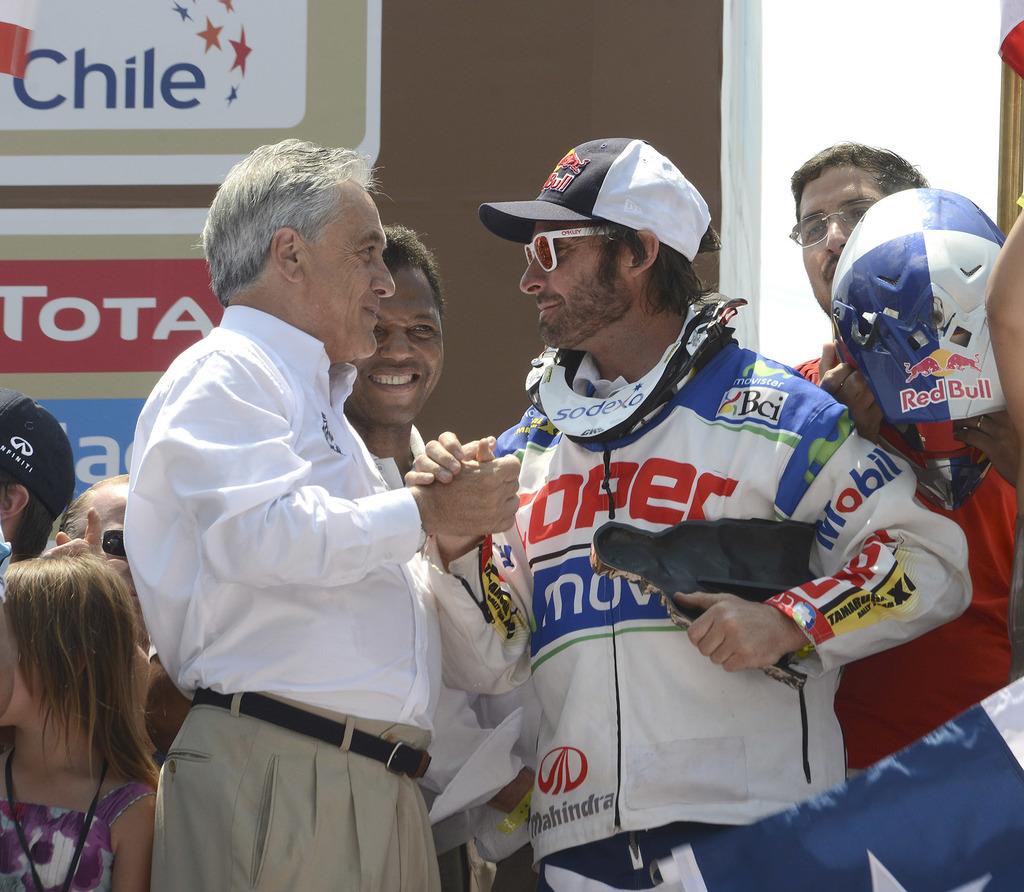What is the name of the country on the banner in the top left of the image?
Give a very brief answer. Chile. What drink is on the helmet?
Your answer should be compact. Red bull. 